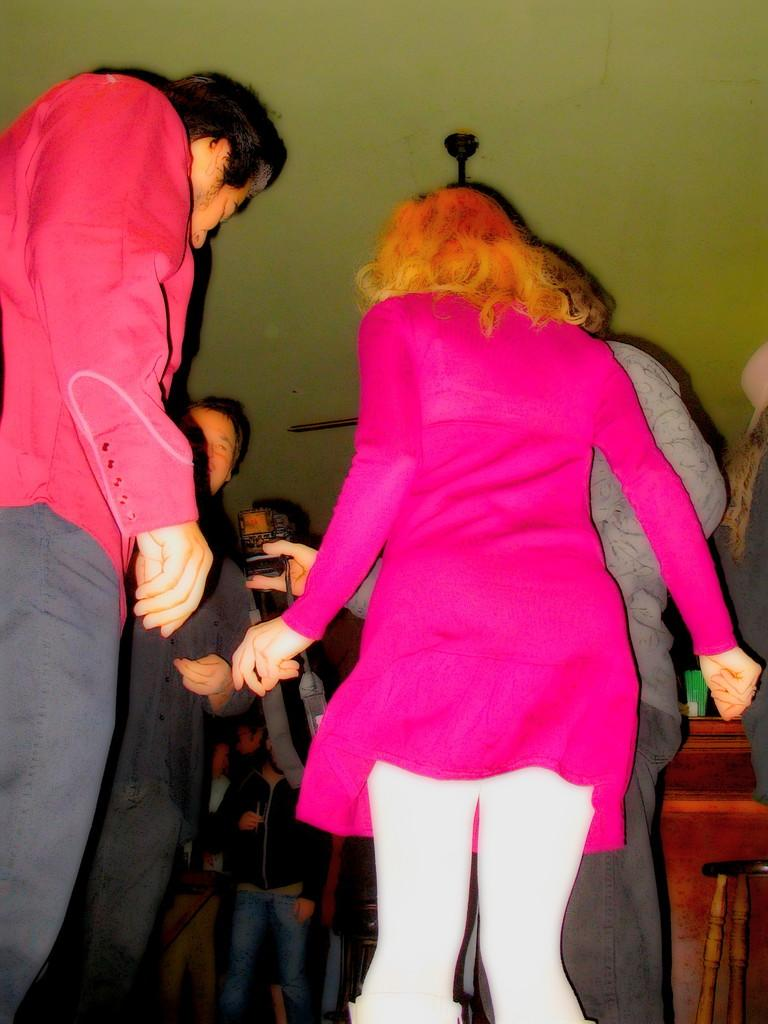How many people are in the image? There are people in the image. What is one person doing in the image? One person is holding a camera. What object is on the table in the image? There is a glass on a table. What type of furniture is in the image? There is a chair in the image. What is hanging from the ceiling in the image? A ceiling fan is present in the image. What type of locket is the sister wearing in the image? There is no sister or locket present in the image. What advice does the grandfather give to the person holding the camera in the image? There is no grandfather present in the image, so it's not possible to determine any advice he might give. 